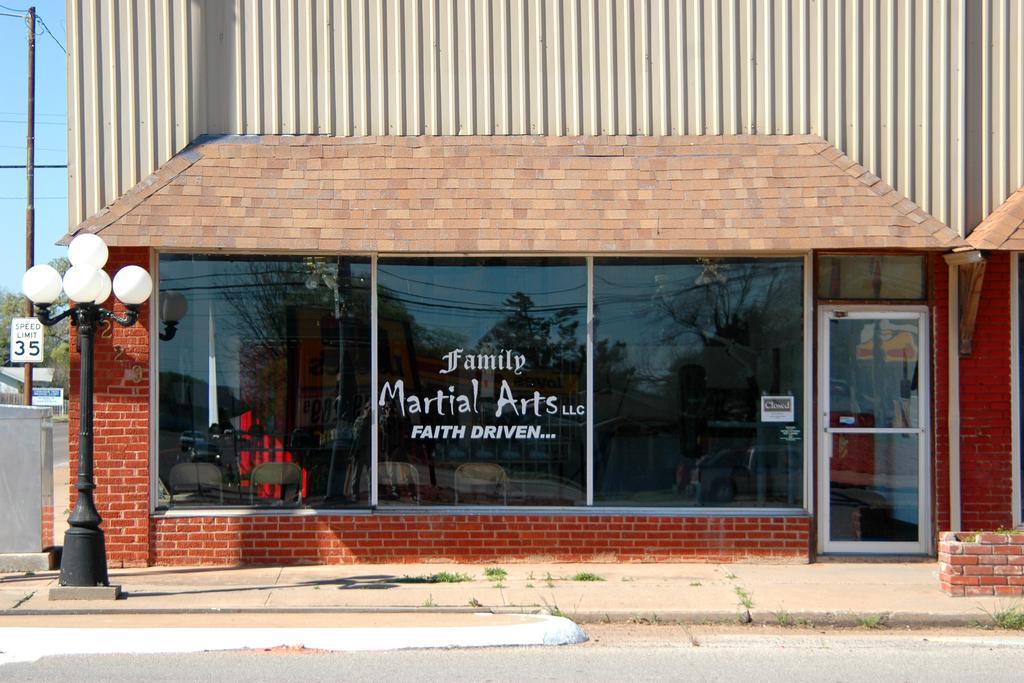Could you give a brief overview of what you see in this image? In this picture we can see a shop with glass windows and a door. Inside the shop, there are chairs and some objects. On the glass windows, we can see the reflections of vehicles, trees, cables and the sky. On the glass window, it is written something. On the left side of the image, there is a pole with lights. Behind the pole, there is another pole with a board and there are trees, cables and the sky. At the top of the image, there is a metal sheet. 